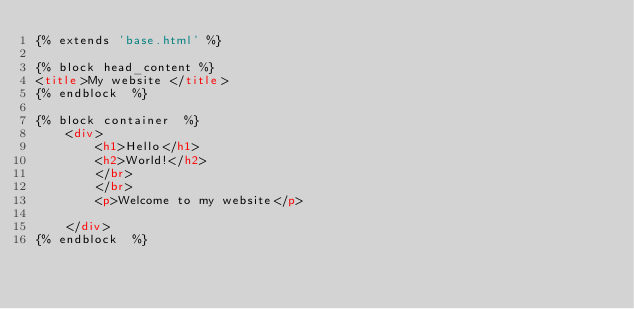Convert code to text. <code><loc_0><loc_0><loc_500><loc_500><_HTML_>{% extends 'base.html' %}

{% block head_content %}
<title>My website </title>
{% endblock  %}

{% block container  %}
    <div>
        <h1>Hello</h1>
        <h2>World!</h2>
        </br>
        </br>
        <p>Welcome to my website</p>
        
    </div>
{% endblock  %}</code> 